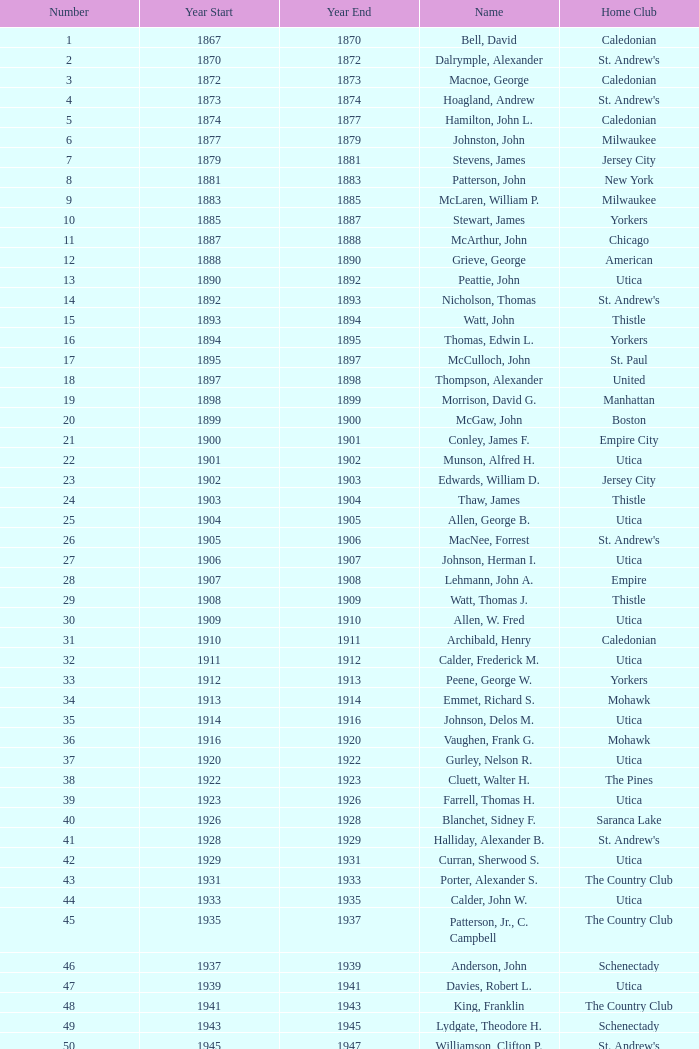Which Number has a Home Club of broomstones, and a Year End smaller than 1999? None. 